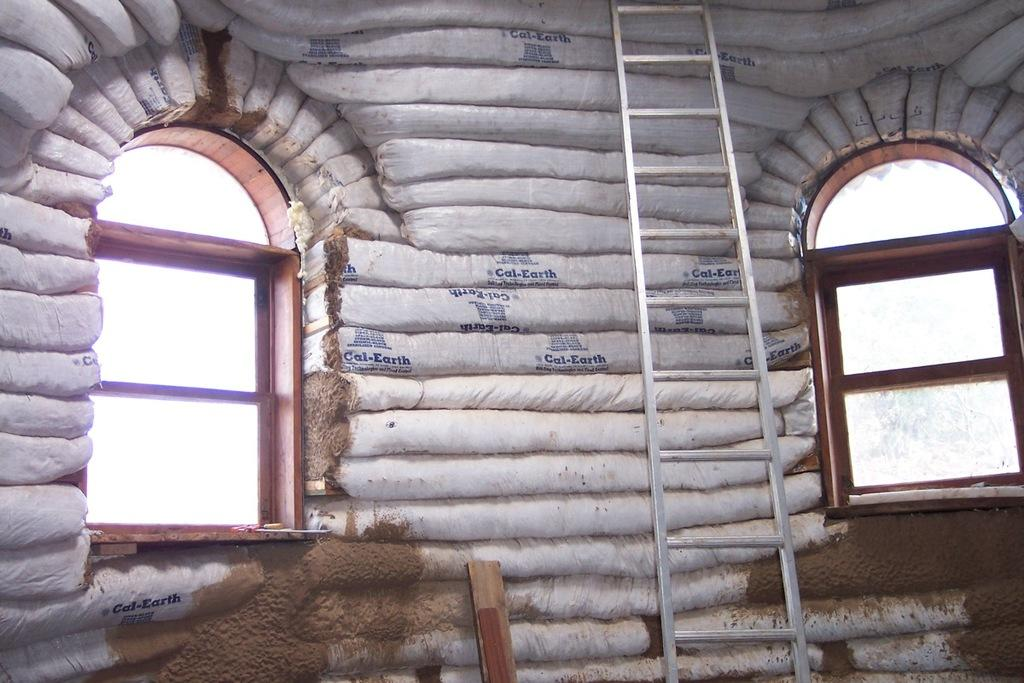What type of location is depicted in the image? The image shows an inside view of a building. What feature of the building can be seen in the image? There is a wall with windows in the image. What object is present in the image that might be used for climbing or reaching high places? A ladder is visible in the image. What other object can be seen in the image that is made of wood? There is a wooden stick in the image. Can you see any icicles hanging from the windows in the image? No, there are no icicles present in the image. What type of quilt is draped over the ladder in the image? There is no quilt present in the image; it only shows a ladder and a wooden stick. 